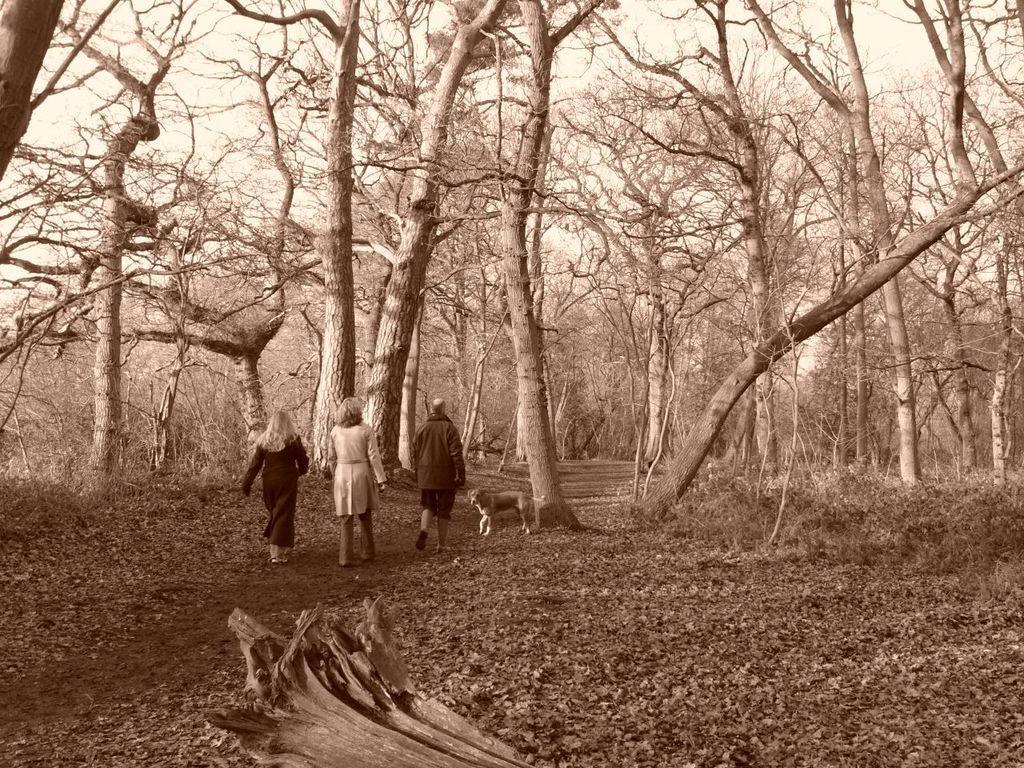How would you summarize this image in a sentence or two? This is a black and white picture. In the middle of the picture, we see three people are walking. Beside them, we see a dog. At the bottom, we see wood, grass and dried leaves. There are trees in the background. 